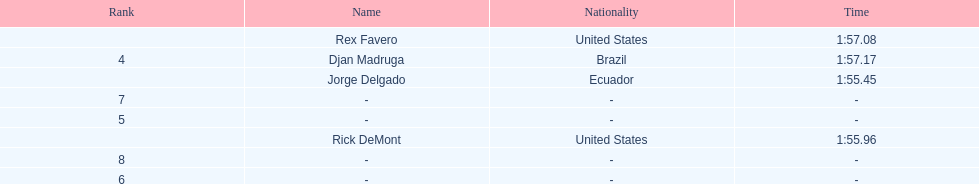Favero finished in 1:57.08. what was the next time? 1:57.17. 